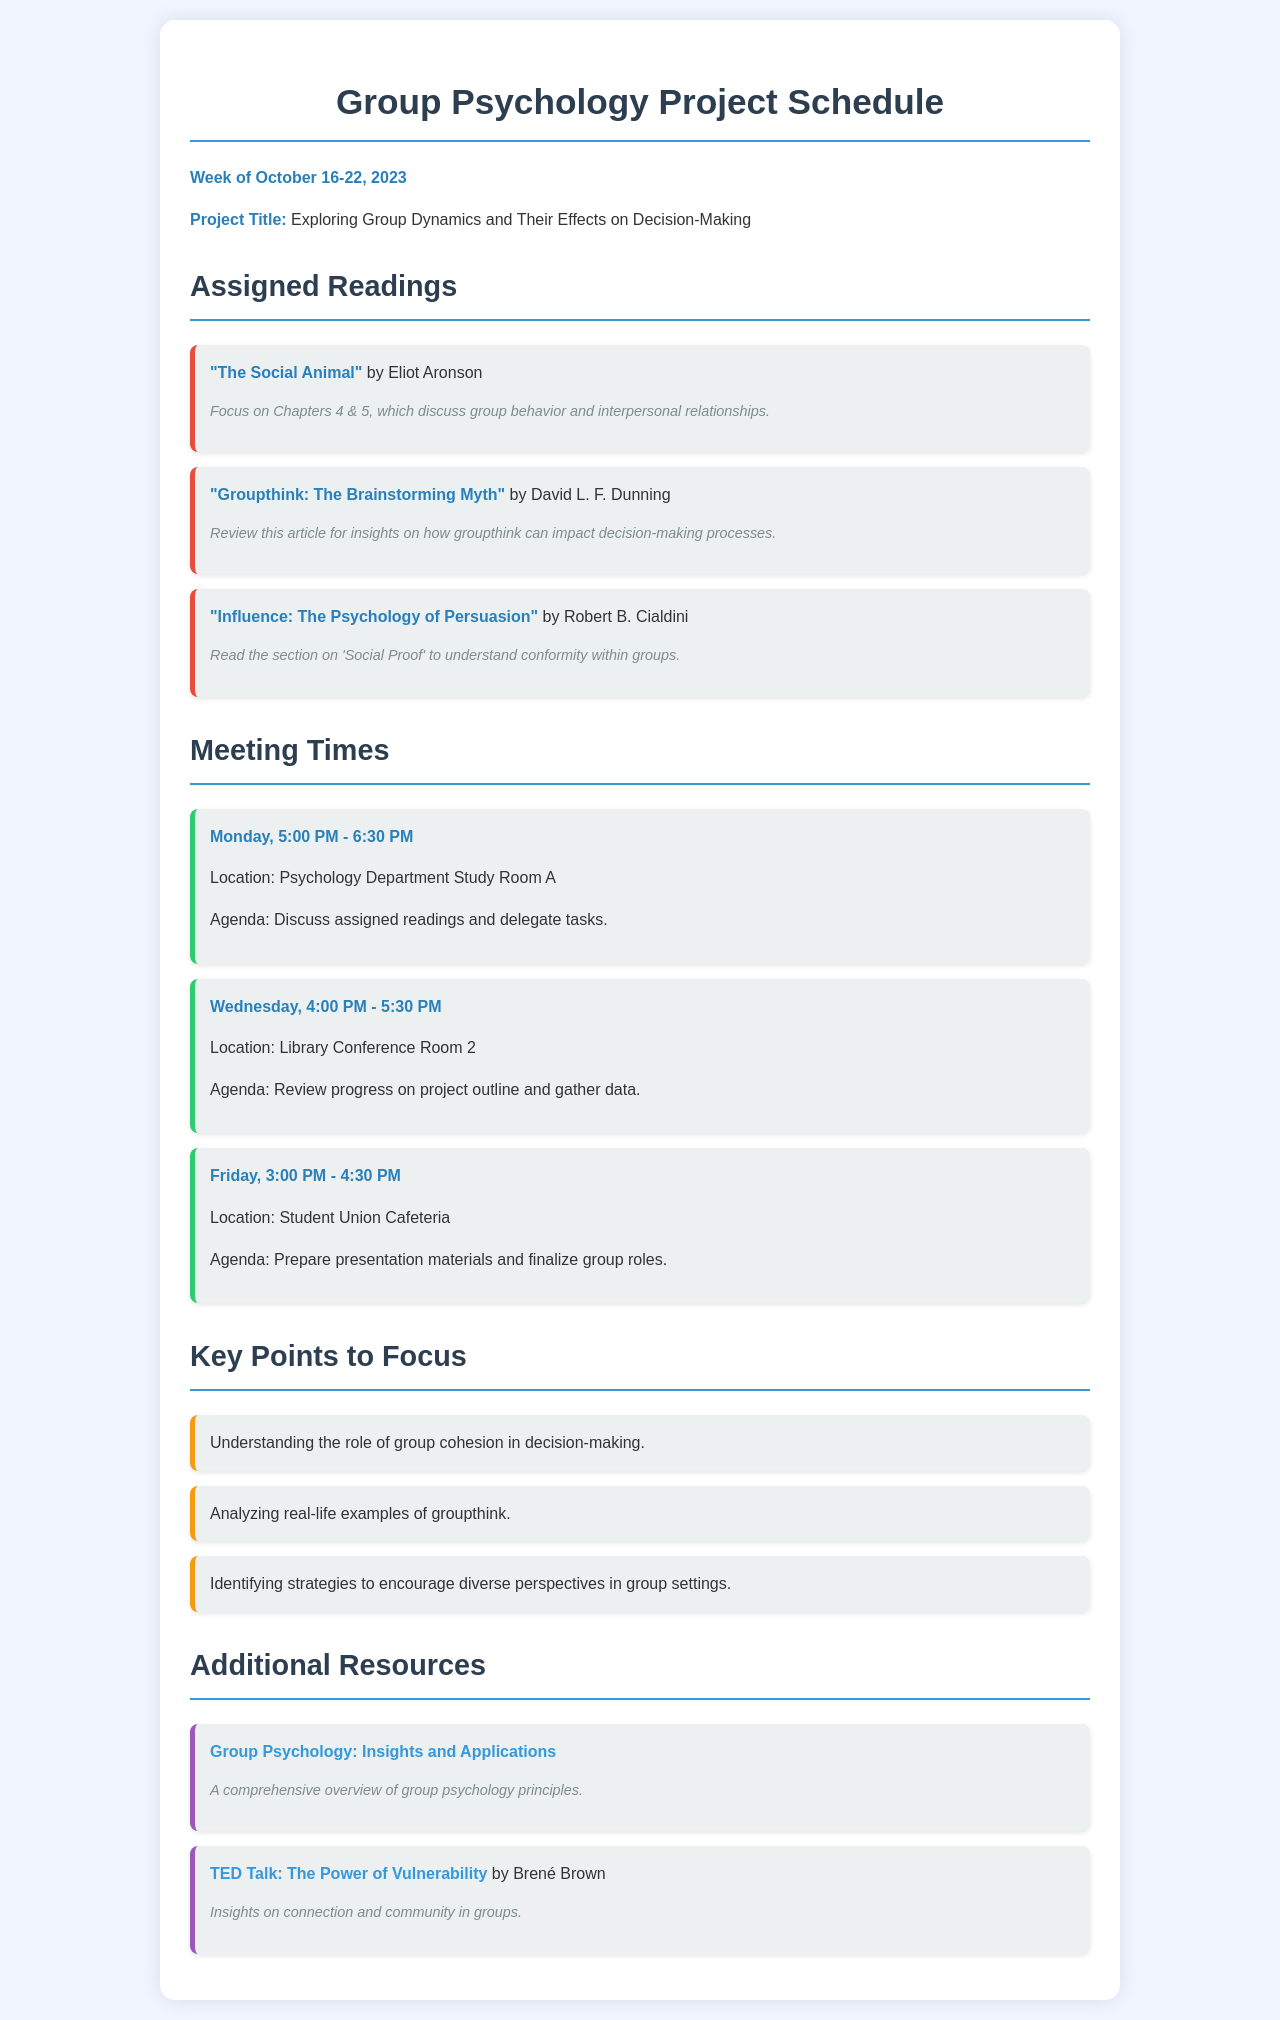What are the assigned readings for the week? The assigned readings list includes titles assigned for understanding group psychology.
Answer: "The Social Animal", "Groupthink: The Brainstorming Myth", "Influence: The Psychology of Persuasion" What is the title of the project? The project title is specified at the top of the schedule to give context to the assigned readings and meetings.
Answer: Exploring Group Dynamics and Their Effects on Decision-Making When is the first meeting scheduled? The schedule lists the days and times of meetings, with the first one appearing at the top of the meeting section.
Answer: Monday, 5:00 PM - 6:30 PM What location is the meeting on Wednesday held? Each meeting includes its location to help participants find where to meet.
Answer: Library Conference Room 2 Which chapter of "The Social Animal" should be focused on? Specific chapters are highlighted in the reading recommendations for targeted study.
Answer: Chapters 4 & 5 How many focus points are there listed in the document? The number of focus points can be counted from the list provided under key points to focus.
Answer: 3 What is one of the key points to focus on? Important points are identified to guide the study and discussion.
Answer: Understanding the role of group cohesion in decision-making Who is the author of "Influence: The Psychology of Persuasion"? The author of the readings provides credibility and context for the content.
Answer: Robert B. Cialdini What is the main agenda for the Friday meeting? Each meeting has a specific agenda listed to guide the discussion and preparation.
Answer: Prepare presentation materials and finalize group roles 